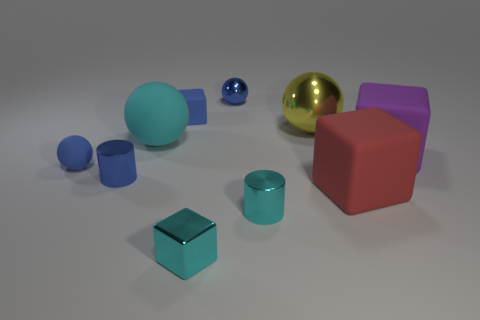What is the big red thing made of?
Offer a very short reply. Rubber. What is the color of the other metal cylinder that is the same size as the blue cylinder?
Keep it short and to the point. Cyan. What shape is the metal object that is the same color as the small shiny sphere?
Give a very brief answer. Cylinder. Do the big purple object and the big red object have the same shape?
Offer a very short reply. Yes. What material is the block that is on the left side of the large purple object and behind the red cube?
Offer a very short reply. Rubber. How big is the cyan cylinder?
Your answer should be compact. Small. What color is the other large rubber object that is the same shape as the purple rubber object?
Provide a succinct answer. Red. Are there any other things that have the same color as the large shiny ball?
Your answer should be compact. No. There is a cyan metallic cylinder behind the shiny cube; is its size the same as the blue metal thing that is behind the purple rubber block?
Keep it short and to the point. Yes. Are there an equal number of cylinders to the right of the big cyan ball and large things on the left side of the tiny cyan metal block?
Your answer should be compact. Yes. 